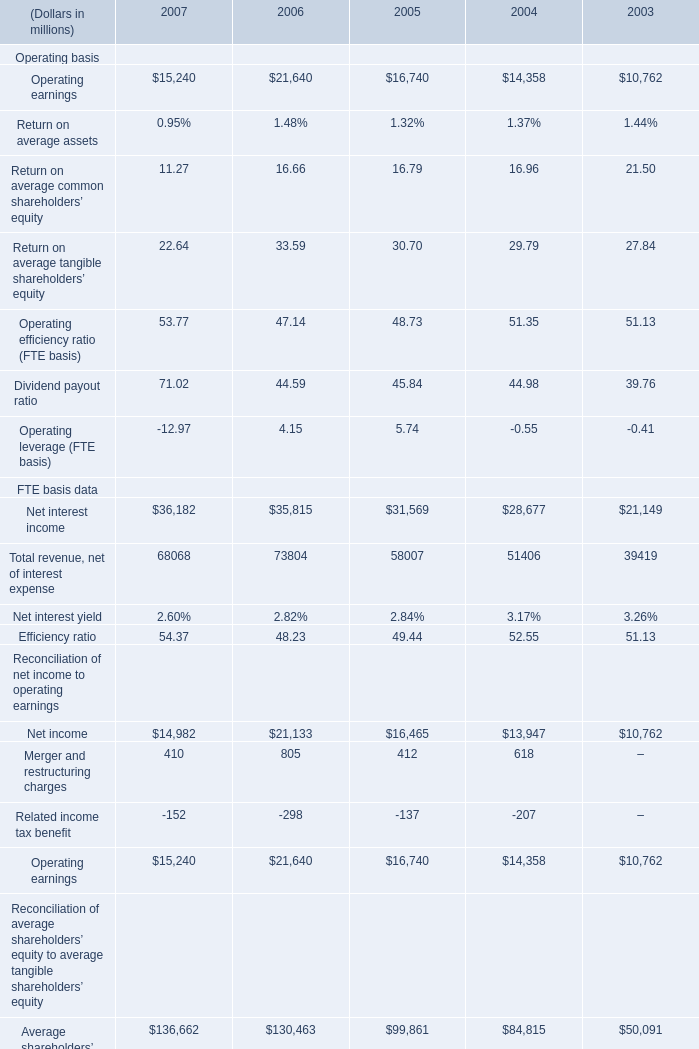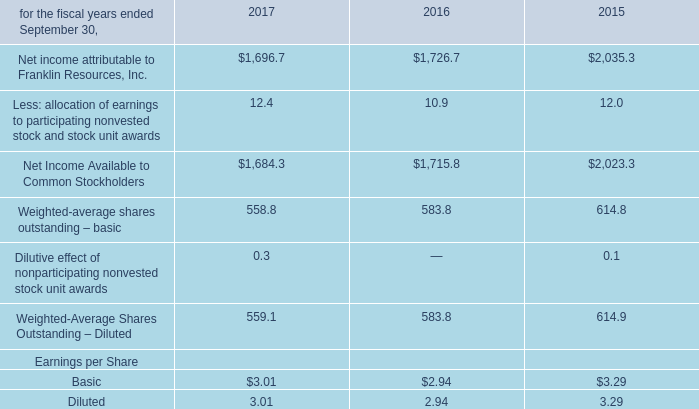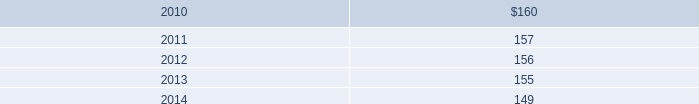what is the annual amortization expense related to bgi transaction of 2009 under a straight-line amortization method , in millions? 
Computations: (163 / 10)
Answer: 16.3. 